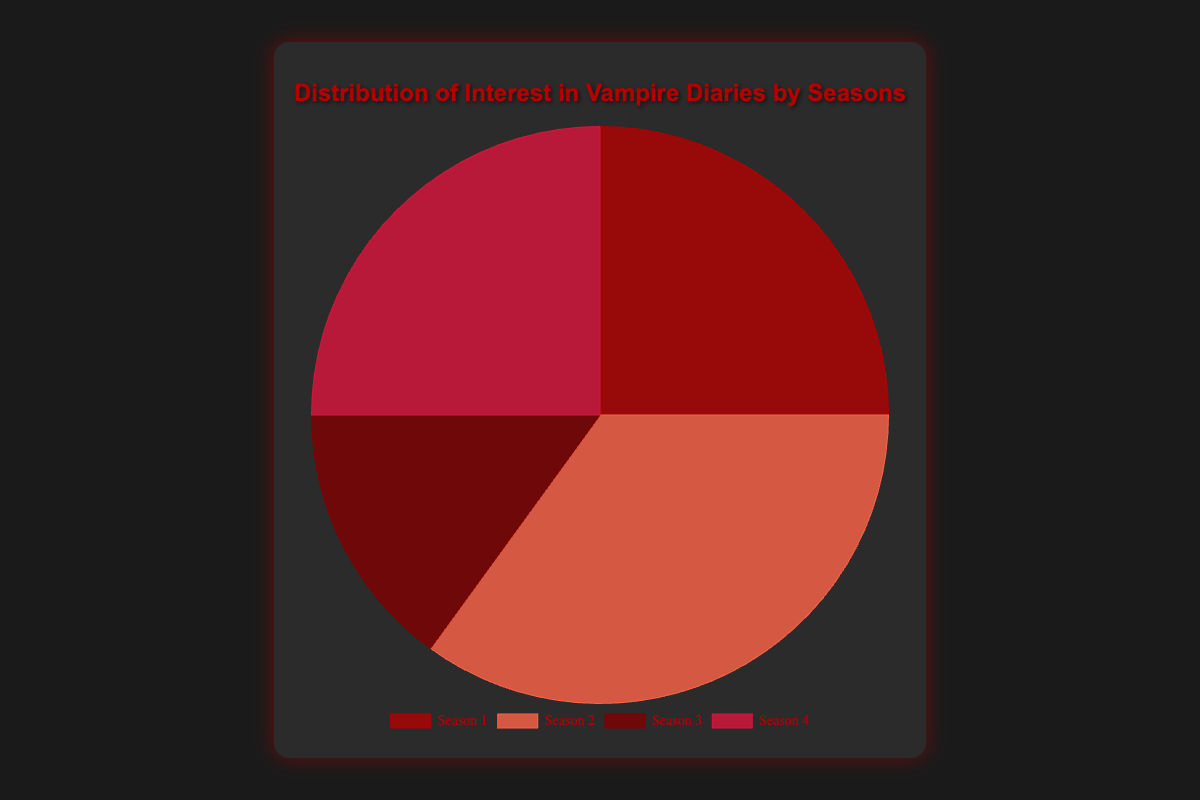Which season has the highest interest? By observing the pie chart, the season with the largest slice represents the highest interest. Season 2 has the highest interest at 35%.
Answer: Season 2 Which two seasons have equal interest? By examining the pie chart, we can see the equal-sized slices. Season 1 and Season 4 both have a 25% interest share.
Answer: Season 1 and Season 4 How much greater is the interest in Season 2 compared to Season 3? Calculate the difference between the percentages of Season 2 (35%) and Season 3 (15%). The difference is 35% - 15% = 20%.
Answer: 20% What is the total interest percentage for Seasons 1 and 4 combined? Add the percentages of Season 1 (25%) and Season 4 (25%). The total is 25% + 25% = 50%.
Answer: 50% What is the average interest percentage of all seasons? Sum all the percentages (25% + 35% + 15% + 25%) and divide by the number of seasons (4). The sum is 100%, and the average is 100% / 4 = 25%.
Answer: 25% Which season has the lowest interest and what is that percentage? Identify the smallest slice in the pie chart, which corresponds to Season 3 with a 15% interest.
Answer: Season 3, 15% Compare the interest in Season 1 to the interest in Season 4. Are they equal, greater, or less? By checking the pie chart, we observe that the slices for Season 1 and Season 4 are equal at 25%.
Answer: Equal Is the combination of interest in Seasons 3 and 4 greater than the interest in Season 2? Sum the interest percentages for Seasons 3 and 4 (15% + 25% = 40%) and compare to Season 2 (35%). Since 40% > 35%, the combination is greater.
Answer: Yes What fraction of the total interest is represented by Season 3? The interest in Season 3 is 15%. The total interest is 100%. The fraction is 15% / 100% = 3/20.
Answer: 3/20 